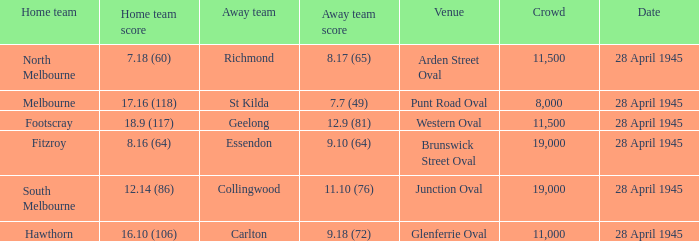Which visiting team has a home team score of 1 11.10 (76). 